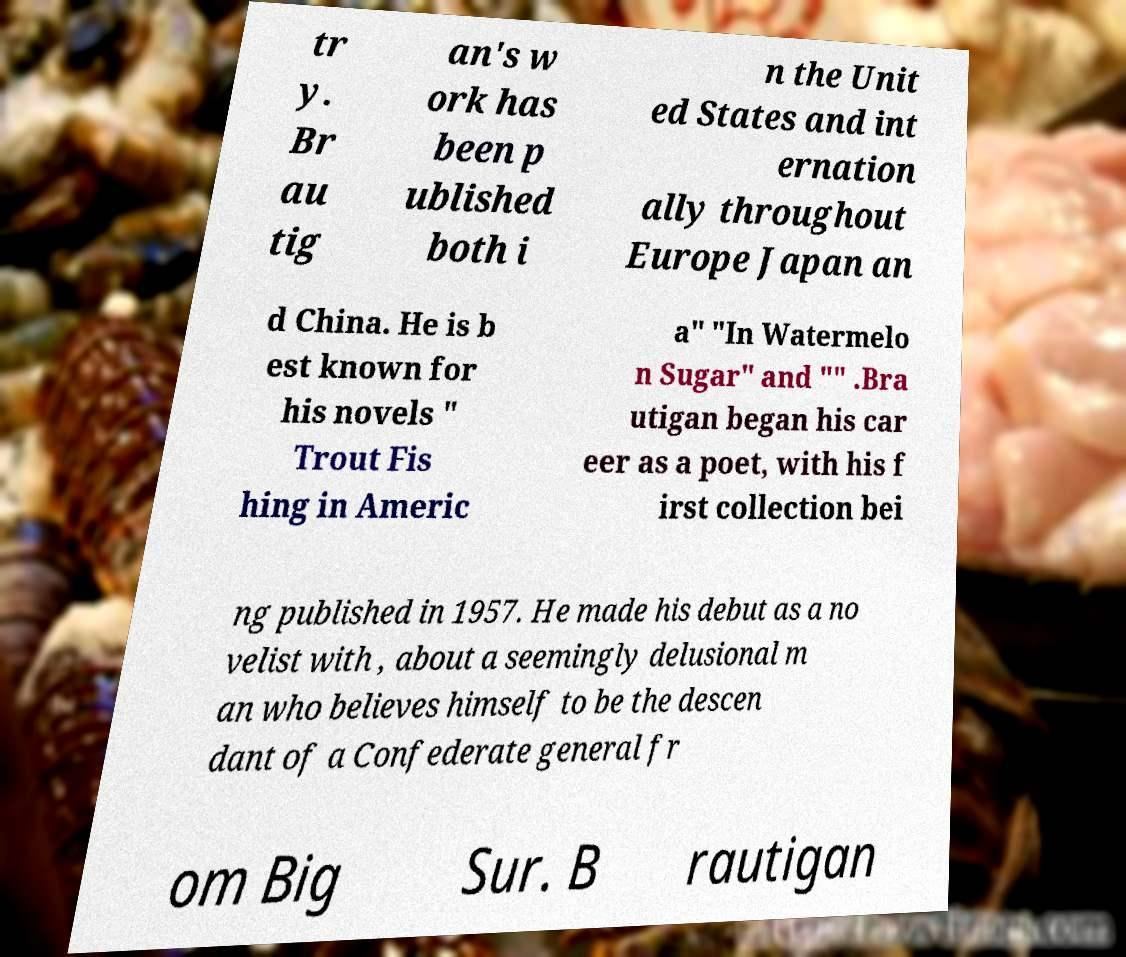I need the written content from this picture converted into text. Can you do that? tr y. Br au tig an's w ork has been p ublished both i n the Unit ed States and int ernation ally throughout Europe Japan an d China. He is b est known for his novels " Trout Fis hing in Americ a" "In Watermelo n Sugar" and "" .Bra utigan began his car eer as a poet, with his f irst collection bei ng published in 1957. He made his debut as a no velist with , about a seemingly delusional m an who believes himself to be the descen dant of a Confederate general fr om Big Sur. B rautigan 